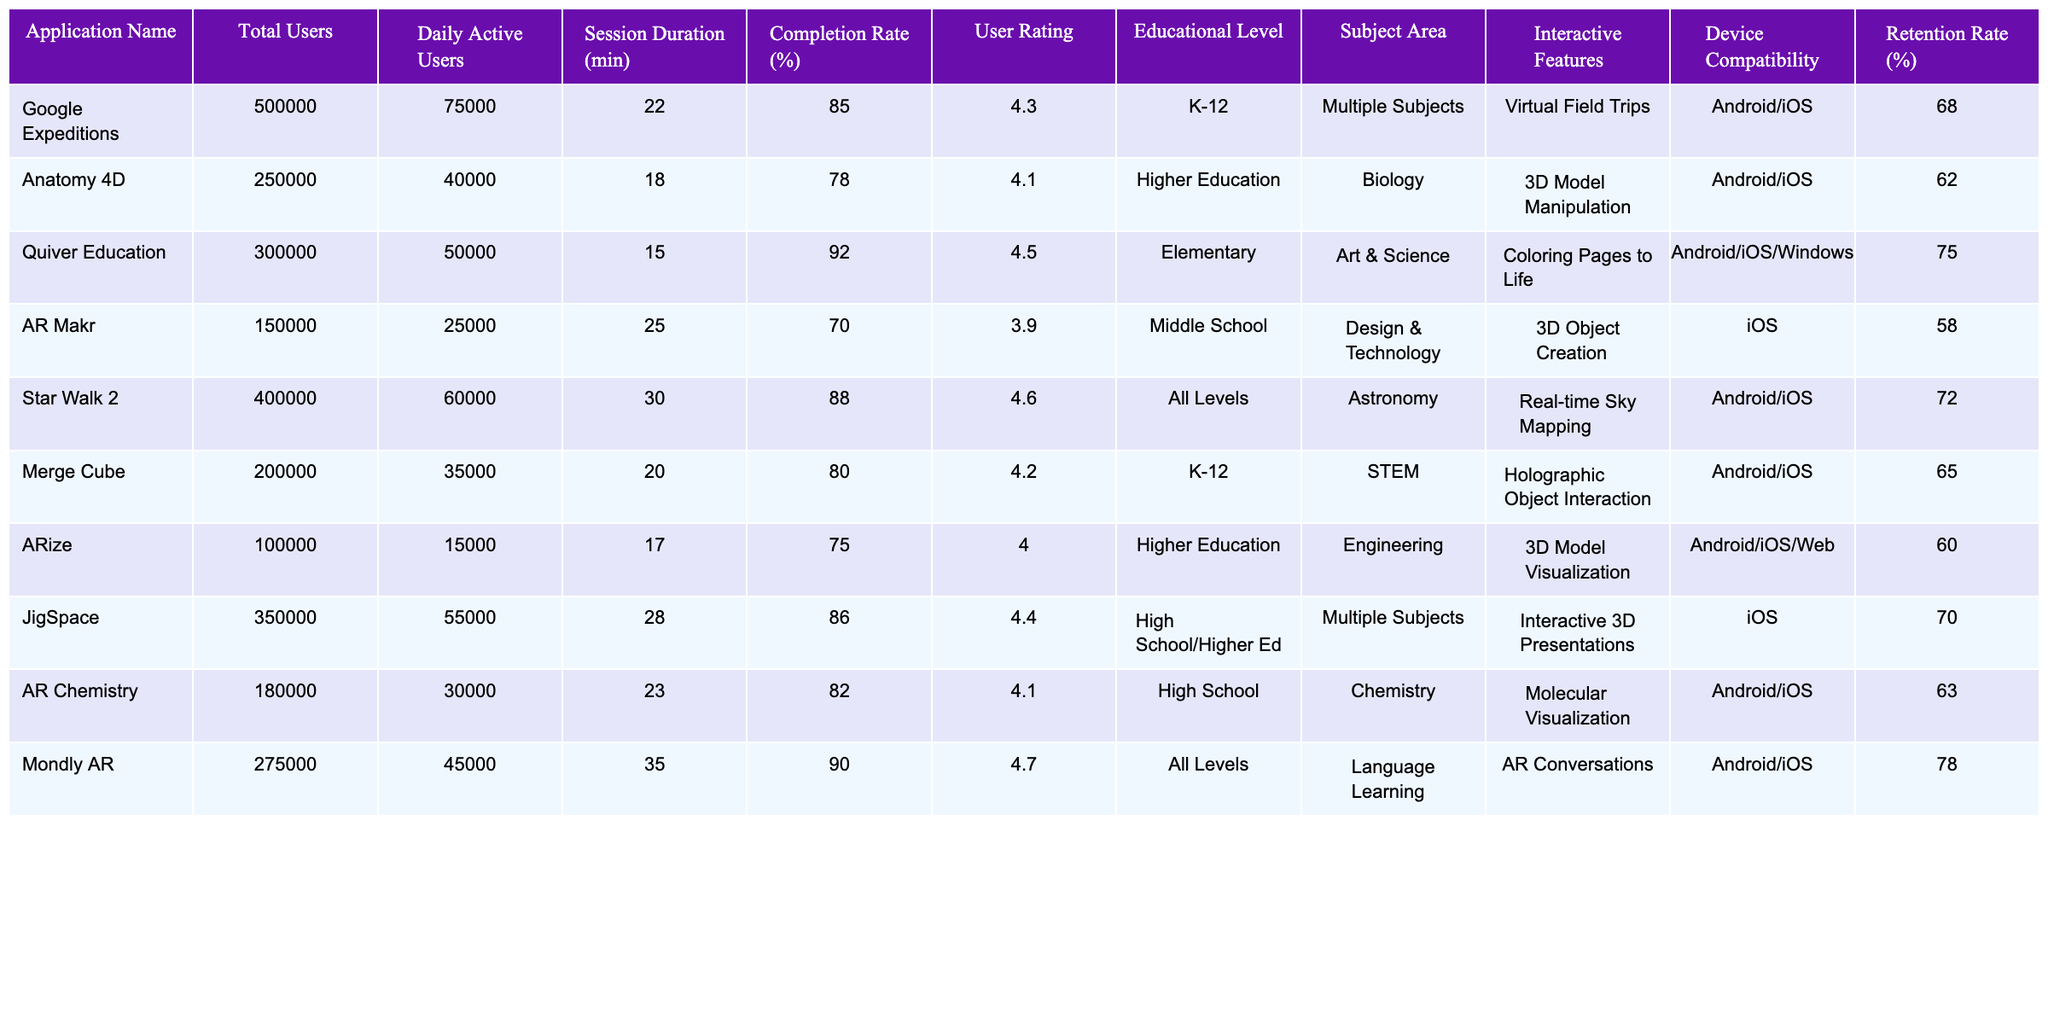What is the user rating of Google Expeditions? The user rating for Google Expeditions is listed directly in the table under the 'User Rating' column. It shows a rating of 4.3.
Answer: 4.3 Which application has the highest retention rate? To find the highest retention rate, compare the 'Retention Rate (%)' values for all applications listed in the table. The highest value is 78% for Mondly AR.
Answer: Mondly AR What is the average session duration of all applications? To calculate the average session duration, sum the 'Session Duration (min)' values: (22 + 18 + 15 + 25 + 30 + 20 + 17 + 28 + 23 + 35) = 243. There are 10 applications, so the average is 243/10 = 24.3 minutes.
Answer: 24.3 minutes Do all applications support both Android and iOS devices? Review the 'Device Compatibility' column for each application. Not all support both Android and iOS; for example, AR Makr only supports iOS. Therefore, not all applications support both platforms.
Answer: No Which educational level has the most applications listed? To find out, count the occurrences of each educational level in the 'Educational Level' column. K-12 appears 2 times, Higher Education 2 times, Elementary 1 time, Middle School 1 time, High School/Higher Ed 1 time, and All Levels 2 times. The levels with the most applications are K-12, Higher Education, and All Levels, each with 2 applications.
Answer: K-12, Higher Education, and All Levels (tie) What is the completion rate of applications in the STEM subject area? Looking at the 'Subject Area' column, Merge Cube is the only application listed under STEM, with a completion rate of 80%.
Answer: 80% Calculate the difference in daily active users between Star Walk 2 and ARize. Star Walk 2 has 60,000 daily active users, and ARize has 15,000. The difference is calculated as 60,000 - 15,000 = 45,000 users.
Answer: 45,000 users Is there any application with a session duration less than 20 minutes? Check the 'Session Duration (min)' column for any values below 20. Quiver Education (15 minutes) fits this criterion.
Answer: Yes What subject area has the highest user rating? Compare the user ratings for each subject area. Mondly AR (Language Learning) has the highest rating at 4.7.
Answer: Language Learning How many applications are compatible with Windows? Count the applications in the 'Device Compatibility' column that include Windows. Only Quiver Education is compatible with Windows.
Answer: 1 